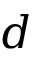<formula> <loc_0><loc_0><loc_500><loc_500>d</formula> 